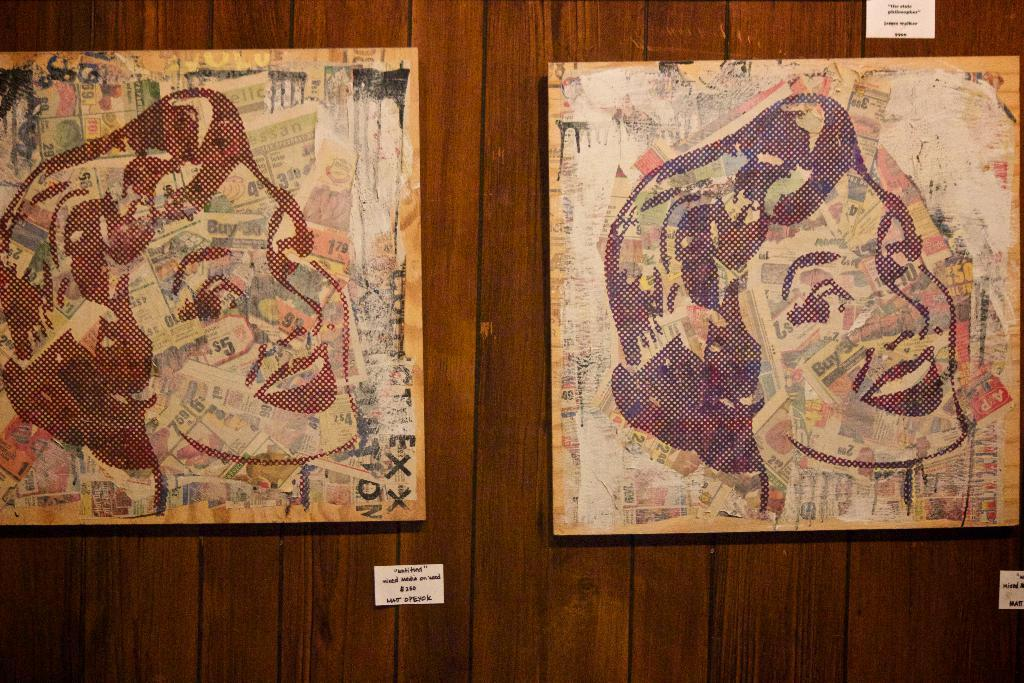What is attached to the wall in the image? There are two boards on the wall in the image. What is displayed on the boards? Paintings are present on the boards. How many white color things are on the wall? There are three white color things on the wall. What is written on the white color things? Something is written on the white color things. Can you see any caves in the image? There are no caves present in the image. What color is the orange fruit on the wall? There is no orange fruit present in the image. 